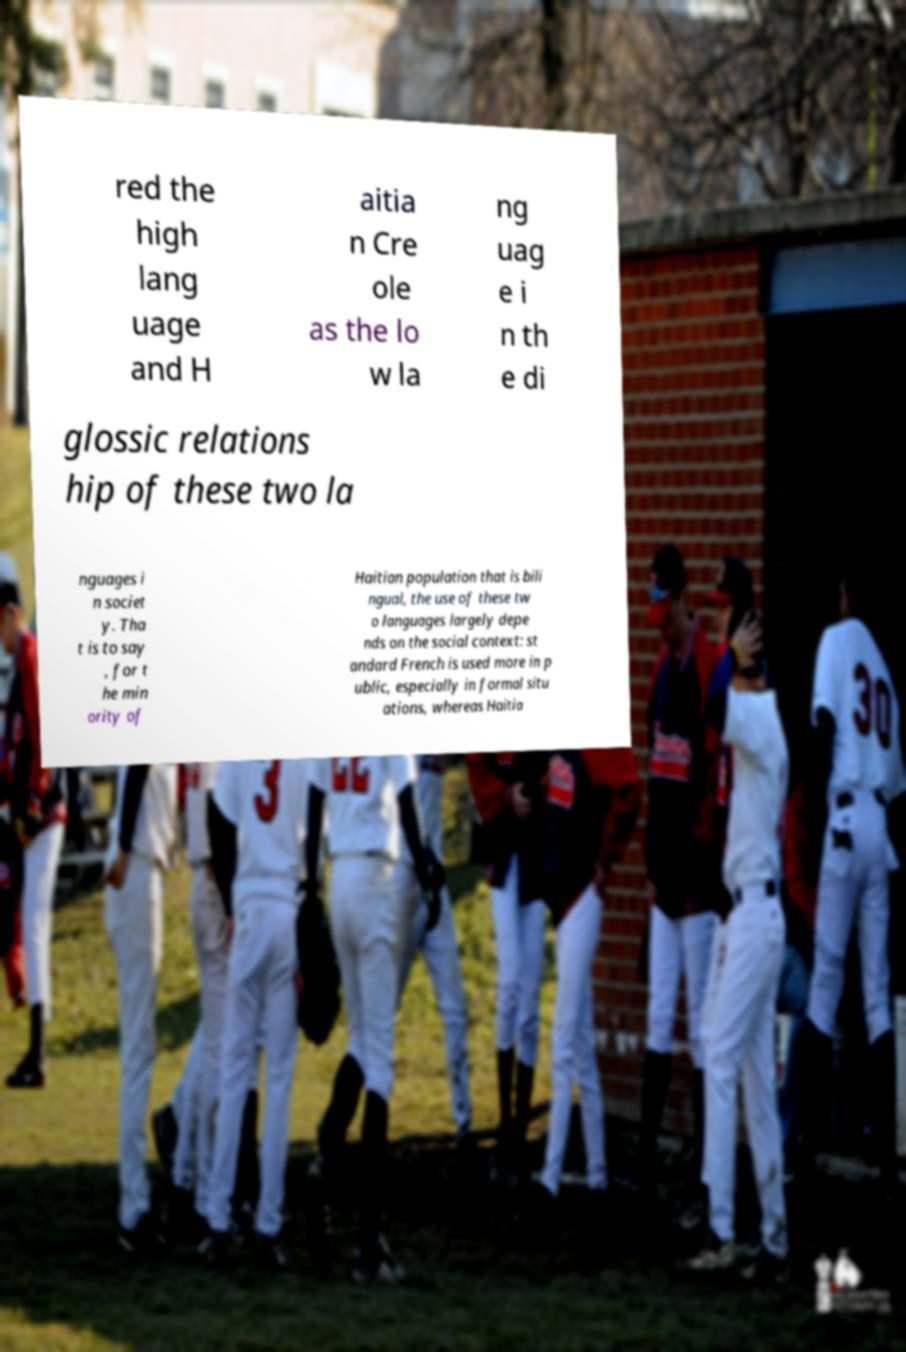What messages or text are displayed in this image? I need them in a readable, typed format. red the high lang uage and H aitia n Cre ole as the lo w la ng uag e i n th e di glossic relations hip of these two la nguages i n societ y. Tha t is to say , for t he min ority of Haitian population that is bili ngual, the use of these tw o languages largely depe nds on the social context: st andard French is used more in p ublic, especially in formal situ ations, whereas Haitia 